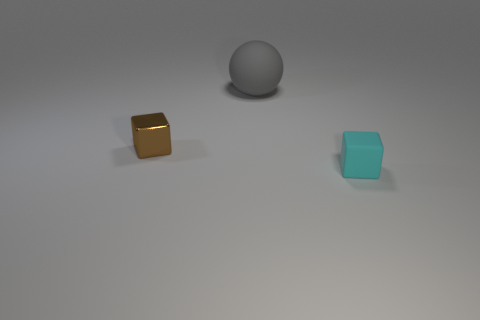Subtract all cubes. How many objects are left? 1 Subtract 1 blocks. How many blocks are left? 1 Add 2 big cyan metal balls. How many objects exist? 5 Subtract 1 cyan blocks. How many objects are left? 2 Subtract all brown blocks. Subtract all cyan cylinders. How many blocks are left? 1 Subtract all brown balls. How many cyan blocks are left? 1 Subtract all gray balls. Subtract all big matte objects. How many objects are left? 1 Add 1 brown things. How many brown things are left? 2 Add 2 tiny blocks. How many tiny blocks exist? 4 Subtract all brown cubes. How many cubes are left? 1 